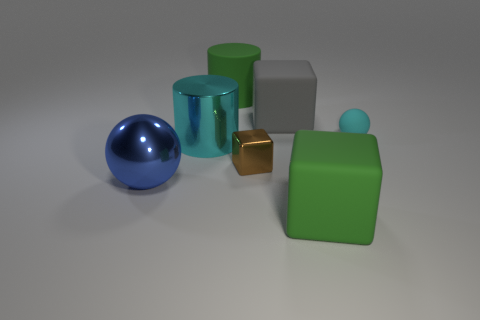What material is the cylinder that is the same color as the small rubber ball?
Provide a short and direct response. Metal. What number of other objects are the same material as the big cyan cylinder?
Your response must be concise. 2. What number of things are big cylinders that are behind the tiny cyan rubber thing or large purple shiny balls?
Your answer should be compact. 1. There is a green rubber object that is behind the green matte thing that is in front of the big blue object; what is its shape?
Provide a succinct answer. Cylinder. Is the shape of the cyan thing on the left side of the tiny matte sphere the same as  the gray object?
Offer a terse response. No. What color is the tiny thing in front of the cyan cylinder?
Ensure brevity in your answer.  Brown. What number of spheres are large cyan things or blue metal objects?
Provide a short and direct response. 1. There is a green rubber thing in front of the cylinder that is behind the small cyan rubber object; how big is it?
Offer a very short reply. Large. Do the shiny cylinder and the ball that is left of the big rubber cylinder have the same color?
Your answer should be very brief. No. What number of small brown shiny objects are in front of the brown metal cube?
Your answer should be compact. 0. 